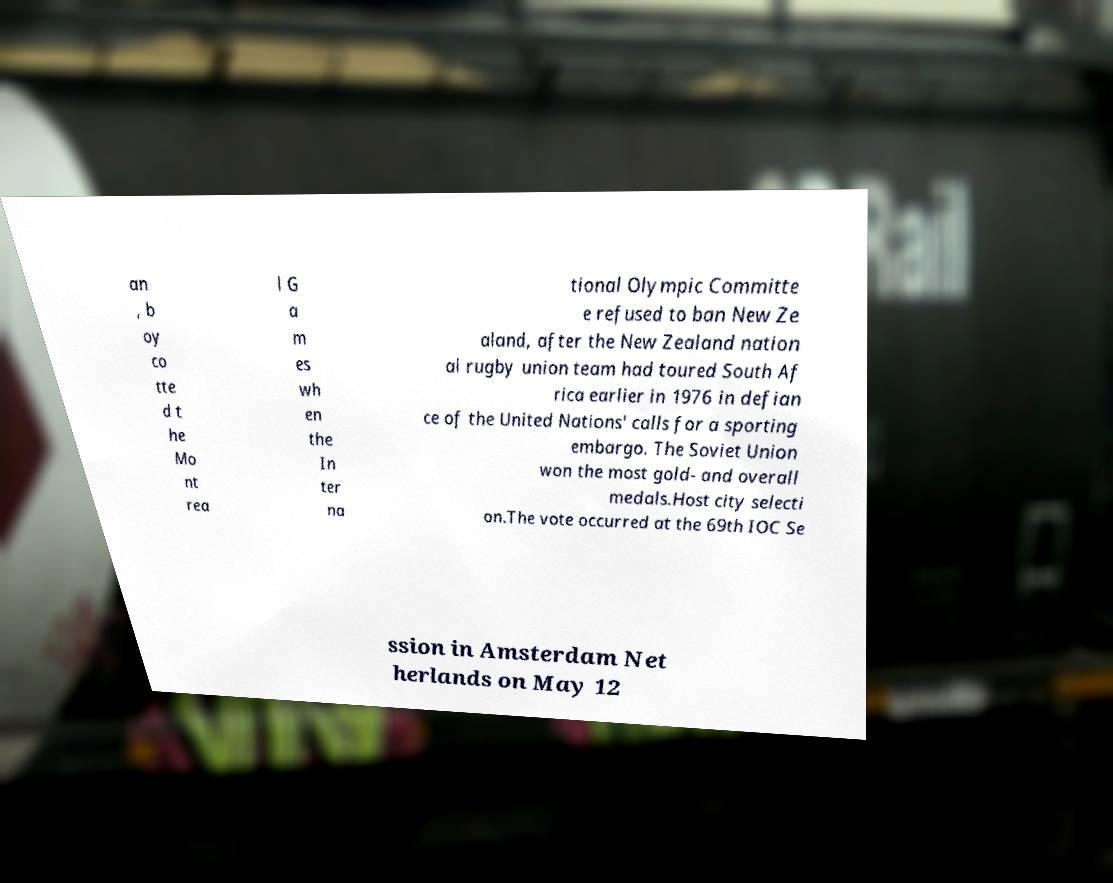For documentation purposes, I need the text within this image transcribed. Could you provide that? an , b oy co tte d t he Mo nt rea l G a m es wh en the In ter na tional Olympic Committe e refused to ban New Ze aland, after the New Zealand nation al rugby union team had toured South Af rica earlier in 1976 in defian ce of the United Nations' calls for a sporting embargo. The Soviet Union won the most gold- and overall medals.Host city selecti on.The vote occurred at the 69th IOC Se ssion in Amsterdam Net herlands on May 12 